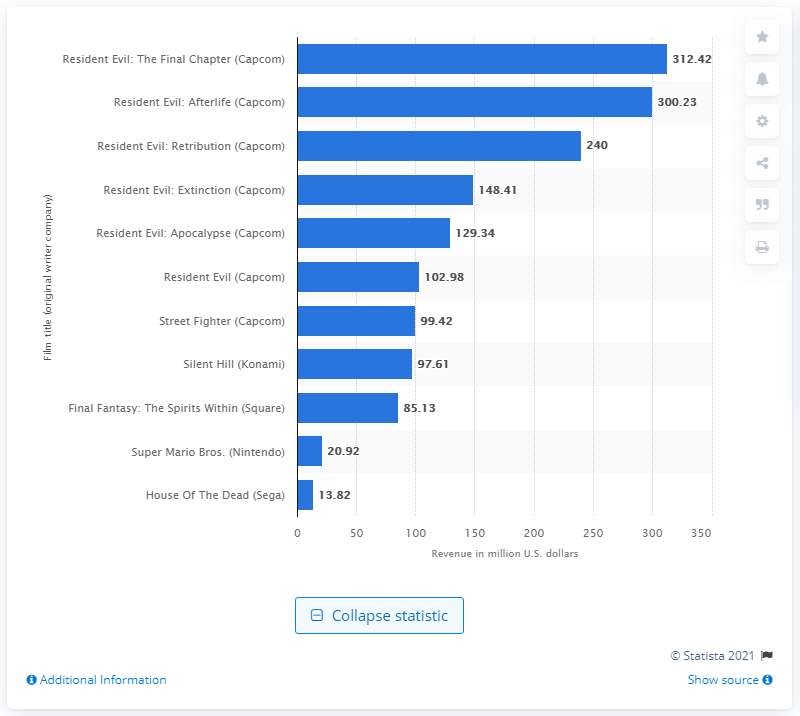Point out several critical features in this image. The total gross income of "Resident Evil: The Final Chapter" is 312.42 million dollars. 